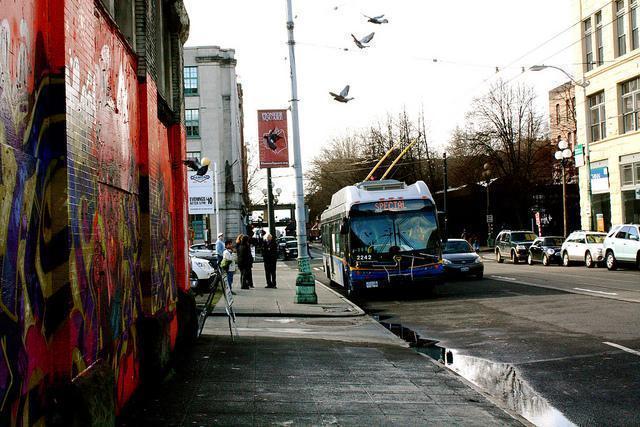What color are the birds flying over the street?
Indicate the correct response by choosing from the four available options to answer the question.
Options: White, black, gray, brown. Gray. 